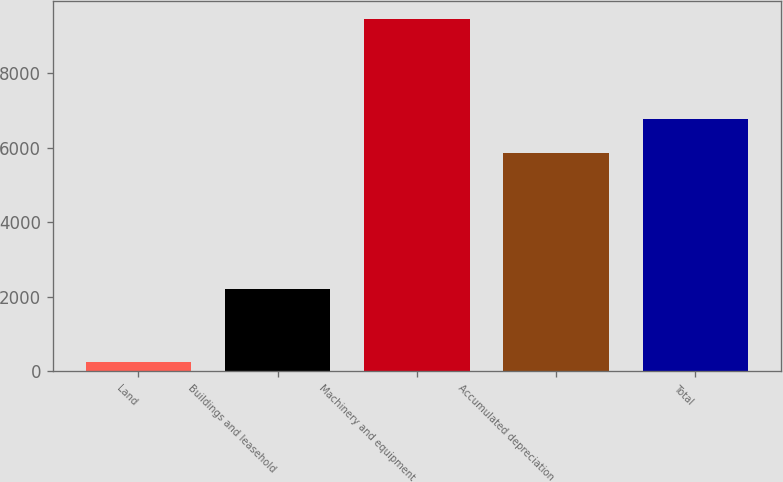Convert chart to OTSL. <chart><loc_0><loc_0><loc_500><loc_500><bar_chart><fcel>Land<fcel>Buildings and leasehold<fcel>Machinery and equipment<fcel>Accumulated depreciation<fcel>Total<nl><fcel>241<fcel>2196<fcel>9464<fcel>5847<fcel>6769.3<nl></chart> 